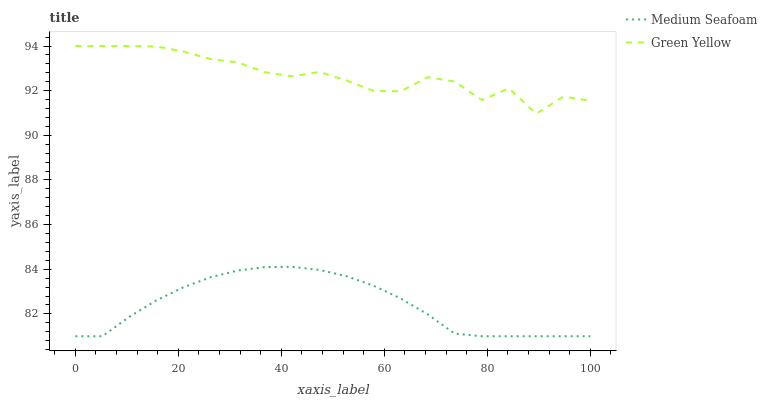Does Medium Seafoam have the minimum area under the curve?
Answer yes or no. Yes. Does Green Yellow have the maximum area under the curve?
Answer yes or no. Yes. Does Medium Seafoam have the maximum area under the curve?
Answer yes or no. No. Is Medium Seafoam the smoothest?
Answer yes or no. Yes. Is Green Yellow the roughest?
Answer yes or no. Yes. Is Medium Seafoam the roughest?
Answer yes or no. No. Does Medium Seafoam have the lowest value?
Answer yes or no. Yes. Does Green Yellow have the highest value?
Answer yes or no. Yes. Does Medium Seafoam have the highest value?
Answer yes or no. No. Is Medium Seafoam less than Green Yellow?
Answer yes or no. Yes. Is Green Yellow greater than Medium Seafoam?
Answer yes or no. Yes. Does Medium Seafoam intersect Green Yellow?
Answer yes or no. No. 